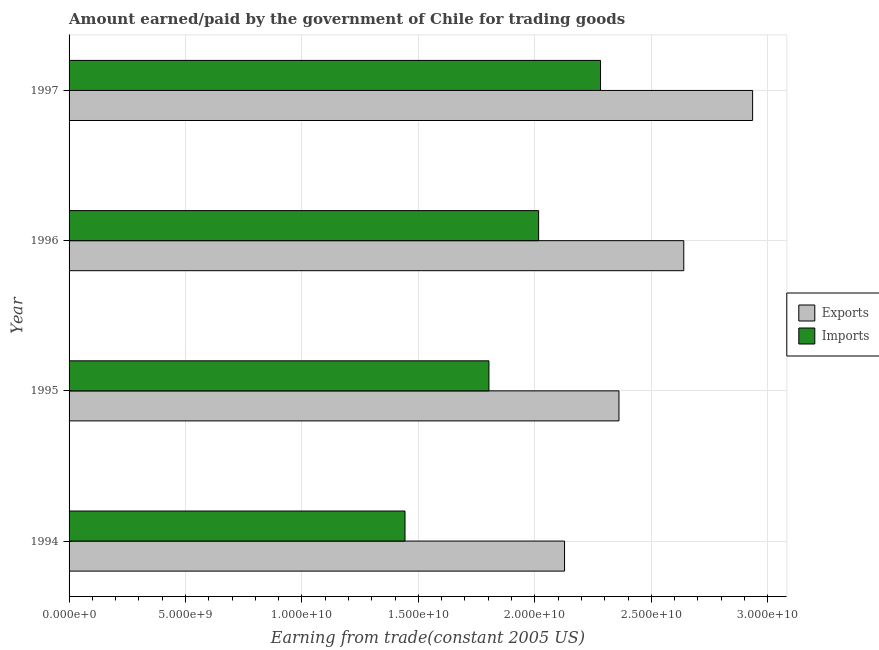How many different coloured bars are there?
Provide a succinct answer. 2. How many groups of bars are there?
Keep it short and to the point. 4. Are the number of bars per tick equal to the number of legend labels?
Offer a very short reply. Yes. In how many cases, is the number of bars for a given year not equal to the number of legend labels?
Your answer should be compact. 0. What is the amount earned from exports in 1996?
Keep it short and to the point. 2.64e+1. Across all years, what is the maximum amount earned from exports?
Ensure brevity in your answer.  2.94e+1. Across all years, what is the minimum amount paid for imports?
Your answer should be very brief. 1.44e+1. In which year was the amount paid for imports minimum?
Provide a succinct answer. 1994. What is the total amount paid for imports in the graph?
Offer a very short reply. 7.54e+1. What is the difference between the amount paid for imports in 1994 and that in 1995?
Keep it short and to the point. -3.60e+09. What is the difference between the amount earned from exports in 1994 and the amount paid for imports in 1997?
Offer a very short reply. -1.55e+09. What is the average amount paid for imports per year?
Give a very brief answer. 1.89e+1. In the year 1995, what is the difference between the amount earned from exports and amount paid for imports?
Your response must be concise. 5.58e+09. In how many years, is the amount paid for imports greater than 29000000000 US$?
Offer a terse response. 0. What is the ratio of the amount paid for imports in 1995 to that in 1997?
Provide a short and direct response. 0.79. Is the amount earned from exports in 1994 less than that in 1996?
Your answer should be compact. Yes. What is the difference between the highest and the second highest amount paid for imports?
Provide a short and direct response. 2.66e+09. What is the difference between the highest and the lowest amount paid for imports?
Offer a very short reply. 8.40e+09. What does the 2nd bar from the top in 1995 represents?
Keep it short and to the point. Exports. What does the 1st bar from the bottom in 1995 represents?
Offer a terse response. Exports. How many years are there in the graph?
Ensure brevity in your answer.  4. What is the difference between two consecutive major ticks on the X-axis?
Your response must be concise. 5.00e+09. Does the graph contain grids?
Ensure brevity in your answer.  Yes. How many legend labels are there?
Ensure brevity in your answer.  2. How are the legend labels stacked?
Your response must be concise. Vertical. What is the title of the graph?
Provide a short and direct response. Amount earned/paid by the government of Chile for trading goods. Does "By country of asylum" appear as one of the legend labels in the graph?
Ensure brevity in your answer.  No. What is the label or title of the X-axis?
Offer a very short reply. Earning from trade(constant 2005 US). What is the label or title of the Y-axis?
Your response must be concise. Year. What is the Earning from trade(constant 2005 US) of Exports in 1994?
Your answer should be compact. 2.13e+1. What is the Earning from trade(constant 2005 US) of Imports in 1994?
Keep it short and to the point. 1.44e+1. What is the Earning from trade(constant 2005 US) in Exports in 1995?
Provide a short and direct response. 2.36e+1. What is the Earning from trade(constant 2005 US) of Imports in 1995?
Your answer should be very brief. 1.80e+1. What is the Earning from trade(constant 2005 US) in Exports in 1996?
Provide a short and direct response. 2.64e+1. What is the Earning from trade(constant 2005 US) in Imports in 1996?
Provide a short and direct response. 2.02e+1. What is the Earning from trade(constant 2005 US) of Exports in 1997?
Your answer should be very brief. 2.94e+1. What is the Earning from trade(constant 2005 US) of Imports in 1997?
Provide a short and direct response. 2.28e+1. Across all years, what is the maximum Earning from trade(constant 2005 US) of Exports?
Your answer should be compact. 2.94e+1. Across all years, what is the maximum Earning from trade(constant 2005 US) of Imports?
Your answer should be compact. 2.28e+1. Across all years, what is the minimum Earning from trade(constant 2005 US) in Exports?
Give a very brief answer. 2.13e+1. Across all years, what is the minimum Earning from trade(constant 2005 US) of Imports?
Offer a very short reply. 1.44e+1. What is the total Earning from trade(constant 2005 US) of Exports in the graph?
Ensure brevity in your answer.  1.01e+11. What is the total Earning from trade(constant 2005 US) of Imports in the graph?
Your answer should be very brief. 7.54e+1. What is the difference between the Earning from trade(constant 2005 US) of Exports in 1994 and that in 1995?
Your answer should be compact. -2.34e+09. What is the difference between the Earning from trade(constant 2005 US) in Imports in 1994 and that in 1995?
Your answer should be very brief. -3.60e+09. What is the difference between the Earning from trade(constant 2005 US) of Exports in 1994 and that in 1996?
Make the answer very short. -5.12e+09. What is the difference between the Earning from trade(constant 2005 US) in Imports in 1994 and that in 1996?
Your answer should be compact. -5.74e+09. What is the difference between the Earning from trade(constant 2005 US) of Exports in 1994 and that in 1997?
Provide a succinct answer. -8.08e+09. What is the difference between the Earning from trade(constant 2005 US) in Imports in 1994 and that in 1997?
Make the answer very short. -8.40e+09. What is the difference between the Earning from trade(constant 2005 US) of Exports in 1995 and that in 1996?
Give a very brief answer. -2.78e+09. What is the difference between the Earning from trade(constant 2005 US) of Imports in 1995 and that in 1996?
Ensure brevity in your answer.  -2.13e+09. What is the difference between the Earning from trade(constant 2005 US) in Exports in 1995 and that in 1997?
Provide a succinct answer. -5.74e+09. What is the difference between the Earning from trade(constant 2005 US) of Imports in 1995 and that in 1997?
Make the answer very short. -4.79e+09. What is the difference between the Earning from trade(constant 2005 US) of Exports in 1996 and that in 1997?
Your response must be concise. -2.96e+09. What is the difference between the Earning from trade(constant 2005 US) of Imports in 1996 and that in 1997?
Your answer should be very brief. -2.66e+09. What is the difference between the Earning from trade(constant 2005 US) of Exports in 1994 and the Earning from trade(constant 2005 US) of Imports in 1995?
Provide a succinct answer. 3.25e+09. What is the difference between the Earning from trade(constant 2005 US) of Exports in 1994 and the Earning from trade(constant 2005 US) of Imports in 1996?
Ensure brevity in your answer.  1.11e+09. What is the difference between the Earning from trade(constant 2005 US) in Exports in 1994 and the Earning from trade(constant 2005 US) in Imports in 1997?
Offer a terse response. -1.55e+09. What is the difference between the Earning from trade(constant 2005 US) of Exports in 1995 and the Earning from trade(constant 2005 US) of Imports in 1996?
Provide a succinct answer. 3.45e+09. What is the difference between the Earning from trade(constant 2005 US) of Exports in 1995 and the Earning from trade(constant 2005 US) of Imports in 1997?
Offer a very short reply. 7.91e+08. What is the difference between the Earning from trade(constant 2005 US) in Exports in 1996 and the Earning from trade(constant 2005 US) in Imports in 1997?
Ensure brevity in your answer.  3.57e+09. What is the average Earning from trade(constant 2005 US) in Exports per year?
Offer a terse response. 2.52e+1. What is the average Earning from trade(constant 2005 US) of Imports per year?
Your answer should be compact. 1.89e+1. In the year 1994, what is the difference between the Earning from trade(constant 2005 US) of Exports and Earning from trade(constant 2005 US) of Imports?
Make the answer very short. 6.85e+09. In the year 1995, what is the difference between the Earning from trade(constant 2005 US) of Exports and Earning from trade(constant 2005 US) of Imports?
Give a very brief answer. 5.58e+09. In the year 1996, what is the difference between the Earning from trade(constant 2005 US) in Exports and Earning from trade(constant 2005 US) in Imports?
Provide a short and direct response. 6.23e+09. In the year 1997, what is the difference between the Earning from trade(constant 2005 US) in Exports and Earning from trade(constant 2005 US) in Imports?
Offer a very short reply. 6.53e+09. What is the ratio of the Earning from trade(constant 2005 US) of Exports in 1994 to that in 1995?
Your response must be concise. 0.9. What is the ratio of the Earning from trade(constant 2005 US) of Imports in 1994 to that in 1995?
Ensure brevity in your answer.  0.8. What is the ratio of the Earning from trade(constant 2005 US) of Exports in 1994 to that in 1996?
Provide a short and direct response. 0.81. What is the ratio of the Earning from trade(constant 2005 US) in Imports in 1994 to that in 1996?
Provide a succinct answer. 0.72. What is the ratio of the Earning from trade(constant 2005 US) of Exports in 1994 to that in 1997?
Provide a short and direct response. 0.72. What is the ratio of the Earning from trade(constant 2005 US) of Imports in 1994 to that in 1997?
Give a very brief answer. 0.63. What is the ratio of the Earning from trade(constant 2005 US) of Exports in 1995 to that in 1996?
Provide a succinct answer. 0.89. What is the ratio of the Earning from trade(constant 2005 US) of Imports in 1995 to that in 1996?
Provide a succinct answer. 0.89. What is the ratio of the Earning from trade(constant 2005 US) in Exports in 1995 to that in 1997?
Give a very brief answer. 0.8. What is the ratio of the Earning from trade(constant 2005 US) of Imports in 1995 to that in 1997?
Give a very brief answer. 0.79. What is the ratio of the Earning from trade(constant 2005 US) of Exports in 1996 to that in 1997?
Your answer should be very brief. 0.9. What is the ratio of the Earning from trade(constant 2005 US) of Imports in 1996 to that in 1997?
Provide a succinct answer. 0.88. What is the difference between the highest and the second highest Earning from trade(constant 2005 US) of Exports?
Make the answer very short. 2.96e+09. What is the difference between the highest and the second highest Earning from trade(constant 2005 US) in Imports?
Offer a very short reply. 2.66e+09. What is the difference between the highest and the lowest Earning from trade(constant 2005 US) in Exports?
Offer a terse response. 8.08e+09. What is the difference between the highest and the lowest Earning from trade(constant 2005 US) in Imports?
Make the answer very short. 8.40e+09. 